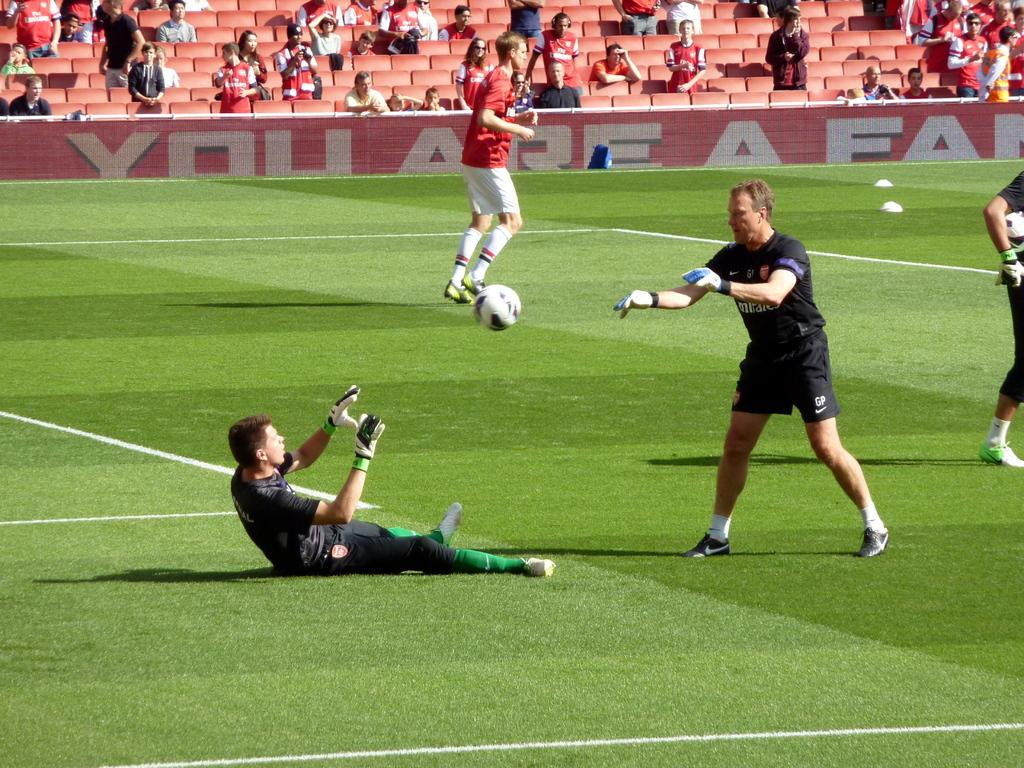<image>
Give a short and clear explanation of the subsequent image. the word you is on the side of the fence next to the field 